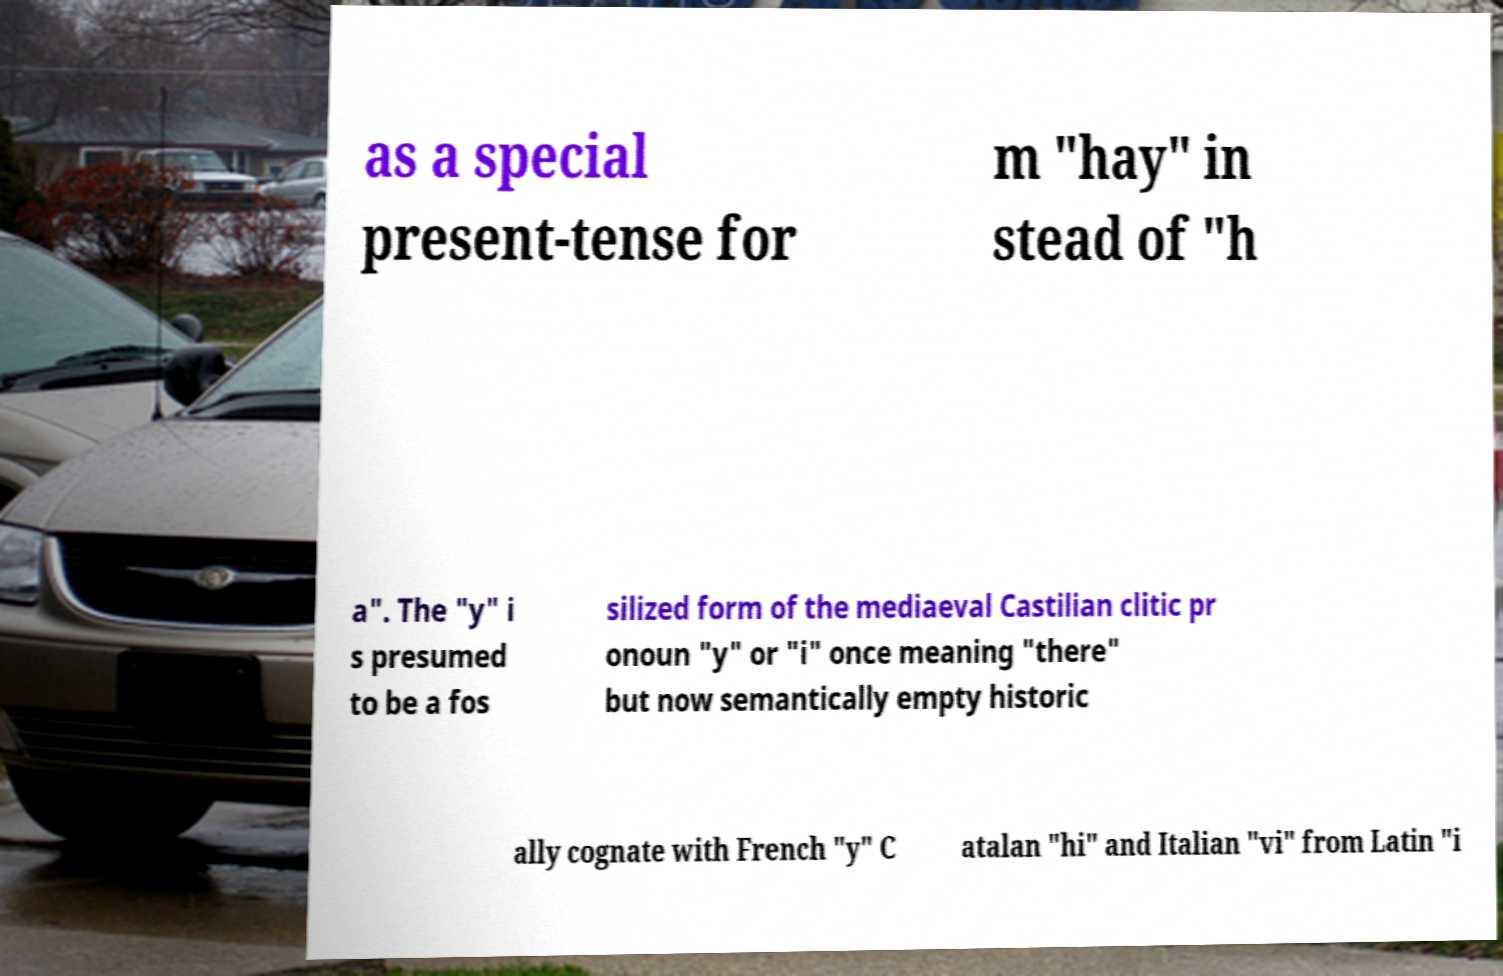Please read and relay the text visible in this image. What does it say? as a special present-tense for m "hay" in stead of "h a". The "y" i s presumed to be a fos silized form of the mediaeval Castilian clitic pr onoun "y" or "i" once meaning "there" but now semantically empty historic ally cognate with French "y" C atalan "hi" and Italian "vi" from Latin "i 